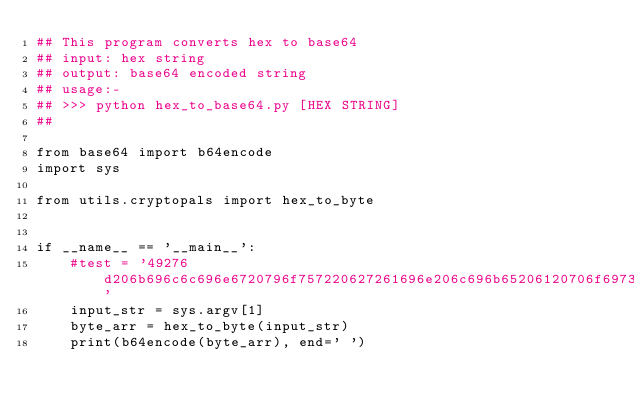<code> <loc_0><loc_0><loc_500><loc_500><_Python_>## This program converts hex to base64
## input: hex string
## output: base64 encoded string
## usage:-
## >>> python hex_to_base64.py [HEX STRING]
##

from base64 import b64encode
import sys

from utils.cryptopals import hex_to_byte


if __name__ == '__main__':
    #test = '49276d206b696c6c696e6720796f757220627261696e206c696b65206120706f69736f6e6f7573206d757368726f6f6d'
    input_str = sys.argv[1]
    byte_arr = hex_to_byte(input_str)
    print(b64encode(byte_arr), end=' ')</code> 